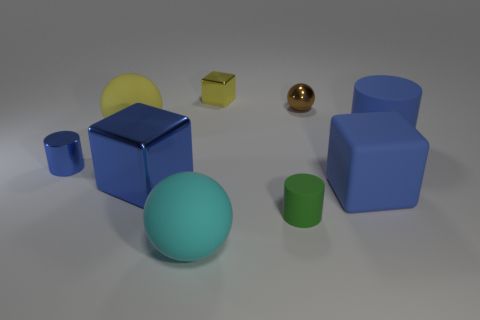There is a large blue matte cylinder; what number of blue matte things are in front of it?
Provide a short and direct response. 1. What number of brown blocks are there?
Your answer should be very brief. 0. Does the green object have the same size as the rubber block?
Your answer should be very brief. No. Are there any metallic spheres in front of the blue shiny thing that is in front of the blue cylinder left of the big cyan sphere?
Provide a short and direct response. No. What is the material of the brown object that is the same shape as the yellow rubber thing?
Your answer should be compact. Metal. What color is the small cylinder to the right of the tiny yellow metal thing?
Ensure brevity in your answer.  Green. The blue matte cylinder is what size?
Your answer should be compact. Large. There is a rubber cube; is its size the same as the shiny cube that is on the right side of the large cyan thing?
Your answer should be very brief. No. There is a object to the left of the large ball that is behind the blue cylinder that is right of the tiny brown shiny sphere; what is its color?
Offer a terse response. Blue. Are the yellow thing on the left side of the cyan rubber ball and the tiny yellow object made of the same material?
Offer a terse response. No. 